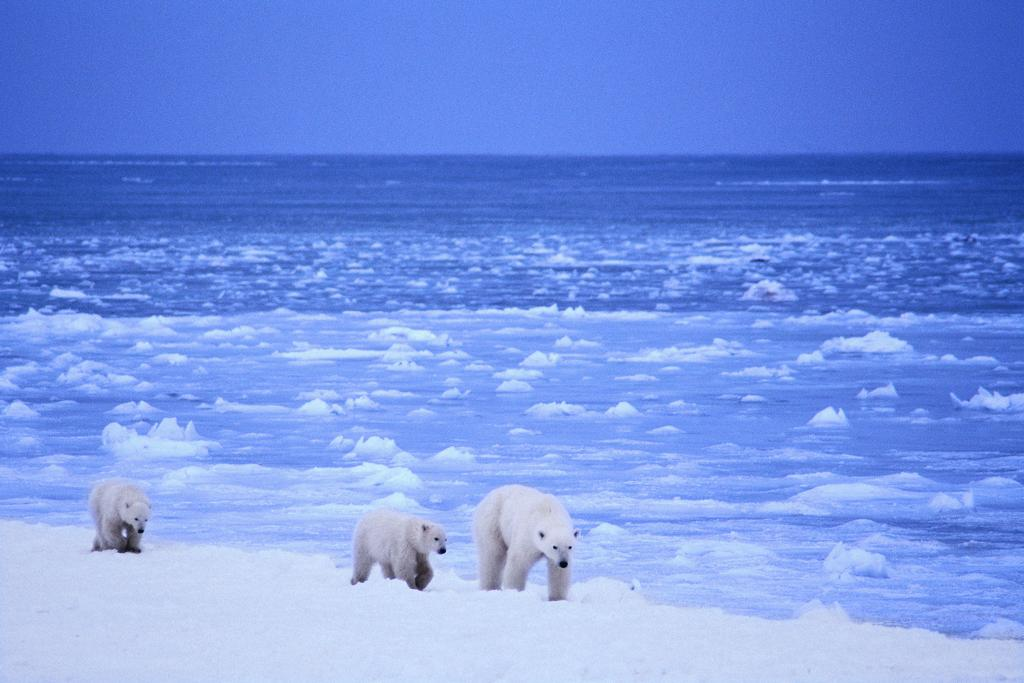What geographical location does the image appear to depict? The image appears to depict the Arctic Ocean. What animals can be seen in the image? There are polar bears in the image. What is the condition of the ice in the image? There is melted ice in the image. What type of tooth is visible in the image? There is no tooth visible in the image. What emotion are the polar bears feeling in the image? The image does not depict the emotions of the polar bears, so it cannot be determined from the image. 